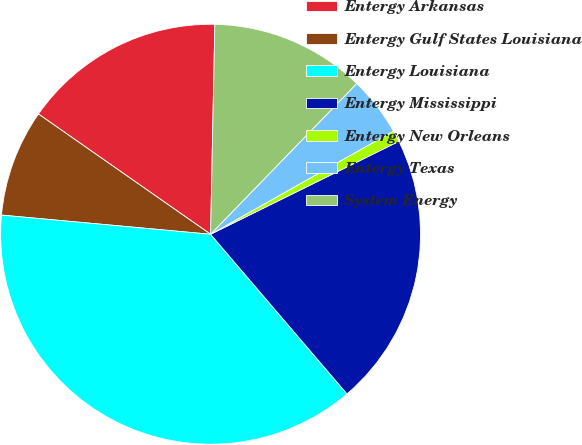<chart> <loc_0><loc_0><loc_500><loc_500><pie_chart><fcel>Entergy Arkansas<fcel>Entergy Gulf States Louisiana<fcel>Entergy Louisiana<fcel>Entergy Mississippi<fcel>Entergy New Orleans<fcel>Entergy Texas<fcel>System Energy<nl><fcel>15.62%<fcel>8.25%<fcel>37.71%<fcel>21.04%<fcel>0.88%<fcel>4.57%<fcel>11.93%<nl></chart> 